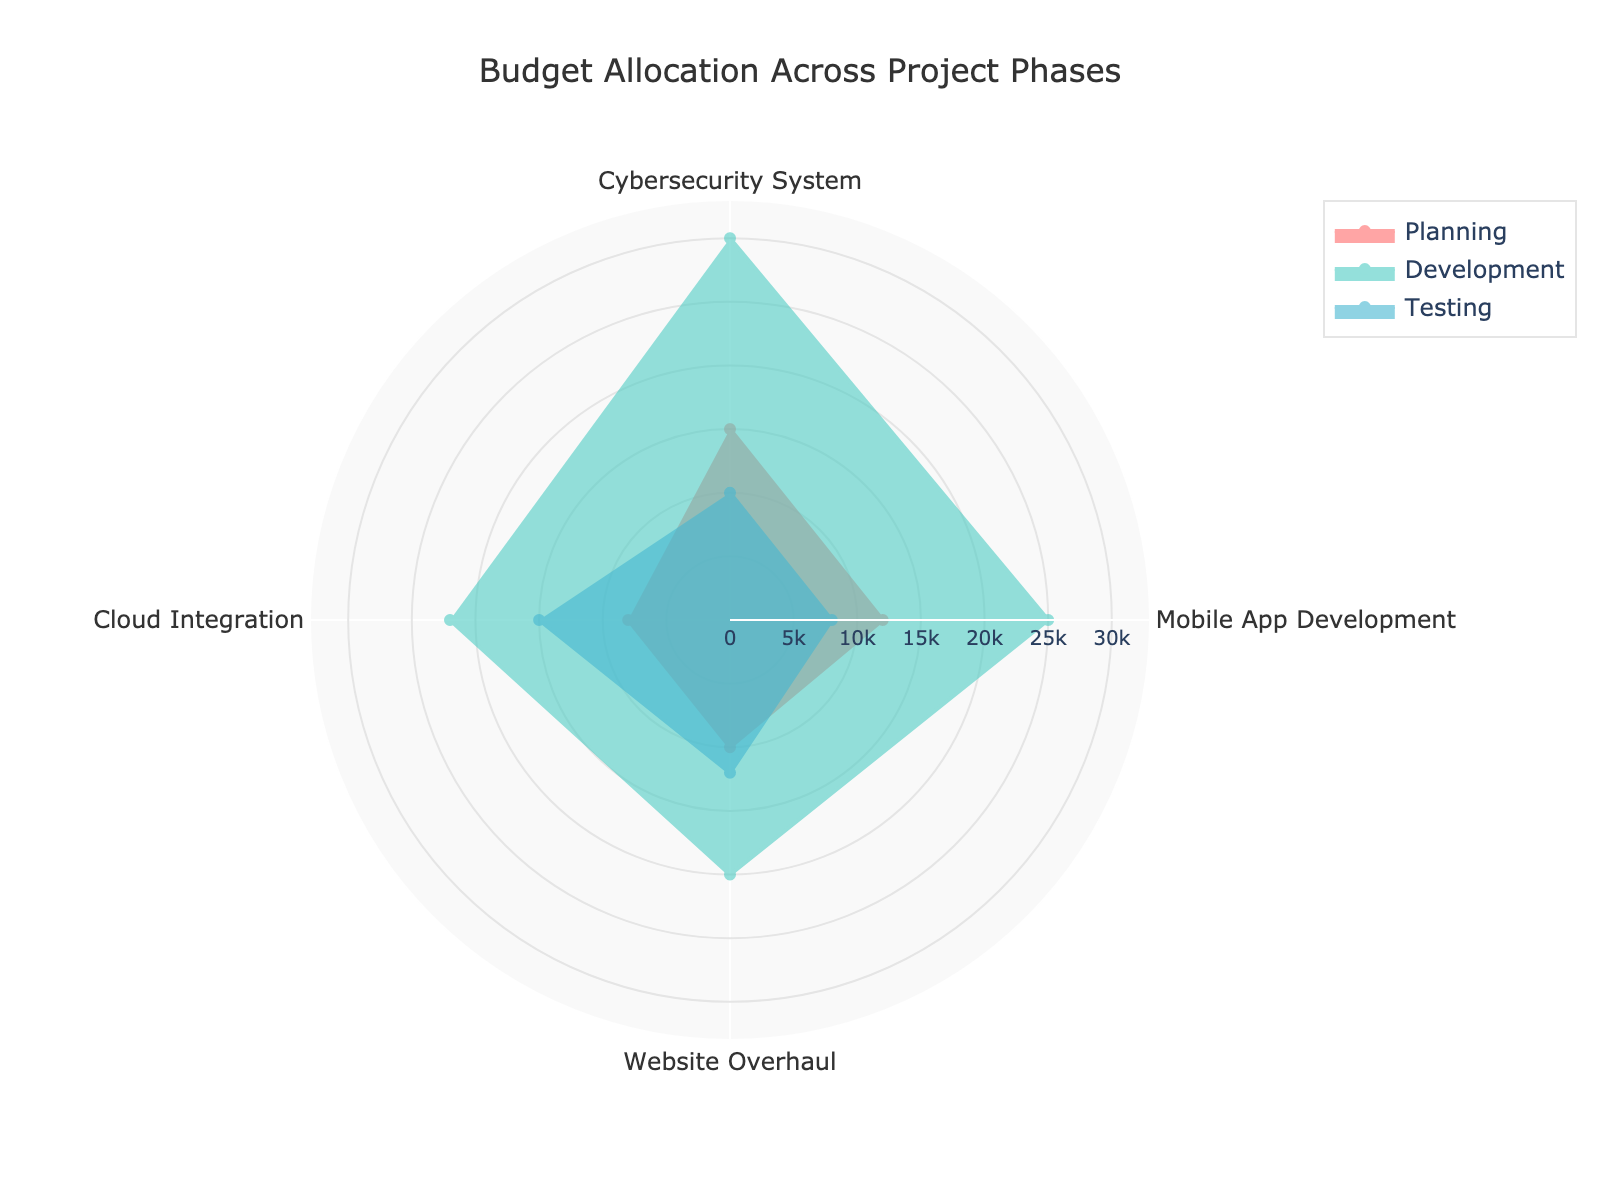What is the title of the figure? The title is usually displayed at the top of the figure in larger font size.
Answer: Budget Allocation Across Project Phases Which project phase has the highest budget allocation in the Cloud Integration project? By comparing the values in the radial arms for the Cloud Integration project, the Development phase has the highest budget allocation of 22000.
Answer: Development What is the budget allocation for Testing in the Website Overhaul project? The value for Testing in the Website Overhaul project can be found in one of the radial arms specific to that project. It is 12000.
Answer: 12000 Compare the budget allocation for Development between Cybersecurity System and Mobile App Development. By looking at the radial arms for Development, Cybersecurity System has a budget of 30000, while Mobile App Development has a budget of 25000. Cybersecurity System has a higher budget.
Answer: Cybersecurity System Which project has the smallest budget allocation for Planning? By checking the values in the radial arm for Planning across all projects, Cloud Integration has the smallest budget allocation of 8000.
Answer: Cloud Integration What is the average budget allocation for Development across all projects? The Development budgets are 30000 (Cybersecurity System), 25000 (Mobile App Development), 20000 (Website Overhaul), and 22000 (Cloud Integration). The average is calculated as (30000 + 25000 + 20000 + 22000) / 4 = 24250.
Answer: 24250 Which phase has the highest overall budget among all projects combined? Summing up the budgets for each phase across all projects, Development has the highest combined budget (30000 + 25000 + 20000 + 22000 = 97000).
Answer: Development In which project phase does the Mobile App Development have the least budget allocation? By comparing the values across phases for the Mobile App Development project, Testing has the least budget allocation of 8000.
Answer: Testing Compare the budget allocations for Testing between the Cybersecurity System and Cloud Integration projects. By how much does one exceed the other? Testing budget for Cybersecurity System is 10000, and for Cloud Integration, it is 15000. Cloud Integration exceeds Cybersecurity System by 15000 - 10000 = 5000.
Answer: 5000 